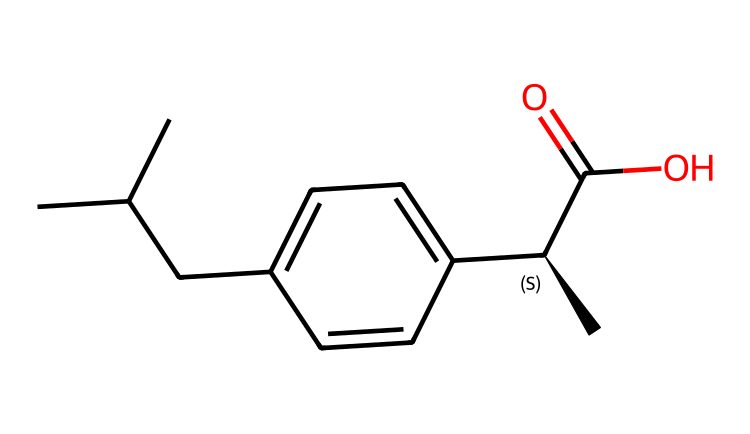What is the main functional group in ibuprofen? The structure includes a carboxylic acid group (-COOH) indicated by the presence of the carbon adjacent to an oxygen with a double bond and a hydroxyl group (-OH).
Answer: carboxylic acid How many carbon atoms are present in ibuprofen? By analyzing the SMILES, we count a total of 13 carbon atoms represented by the 'C' characters in the chain and rings.
Answer: 13 What type of compound is ibuprofen considered to be? Ibuprofen is classified as a nonsteroidal anti-inflammatory drug (NSAID) based on its structure, which includes aliphatic and aromatic components.
Answer: NSAID What is the molecular formula for ibuprofen? By deducing from the SMILES representation, we can count the number of hydrogen atoms along with the previously counted carbon and oxygen atoms to find the complete molecular formula, which is C13H18O2.
Answer: C13H18O2 Which part of the molecule interacts with the body to provide anti-inflammatory effects? The carboxylic acid group is critical because it is essential in binding to enzyme sites that inhibit inflammation pathways within the body.
Answer: carboxylic acid group How many double bonds are present in the structure of ibuprofen? The SMILES shows one double bond between the carbon and oxygen in the carboxylic acid group, which is the only double bond in this structure.
Answer: 1 